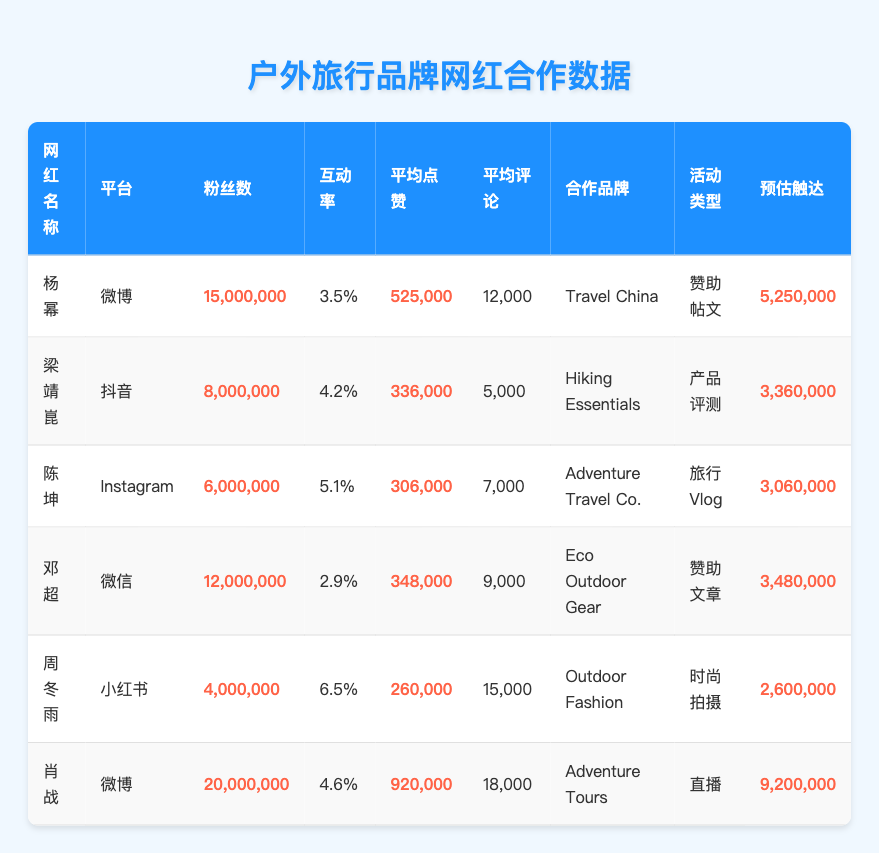What is the engagement rate of Yang Mi? To find the engagement rate for Yang Mi, look at the row corresponding to her name and find the engagement rate value, which is 3.5%.
Answer: 3.5% How many average likes does Xiao Zhan receive? Refer to the row for Xiao Zhan and locate the average likes column; he has an average of 920,000 likes.
Answer: 920,000 Which influencer has the highest number of followers? Check each row's follower count; Xiao Zhan has the highest with 20,000,000 followers.
Answer: 20,000,000 What is the estimated reach of Zhou Dongyu's collaboration? Look at the row for Zhou Dongyu and find the estimated reach value listed as 2,600,000.
Answer: 2,600,000 Which platform does Liang Jingkun use? Identify the row for Liang Jingkun and check the platform column, which shows Douyin.
Answer: Douyin What is the difference in average likes between Chen Kun and Deng Chao? Find the average likes for Chen Kun (306,000) and Deng Chao (348,000). Then calculate the difference: 348,000 - 306,000 = 42,000.
Answer: 42,000 Which influencer has the highest engagement rate? Review the engagement rates of all influencers; Zhou Dongyu has the highest engagement rate of 6.5%.
Answer: 6.5% What is the combined estimated reach of all influencers in the table? Sum the estimated reach of each influencer: 5,250,000 + 3,360,000 + 3,060,000 + 3,480,000 + 2,600,000 + 9,200,000 = 26,950,000.
Answer: 26,950,000 Does Chen Kun have more followers than Deng Chao? Compare the followers of Chen Kun (6,000,000) and Deng Chao (12,000,000); Chen Kun has fewer followers than Deng Chao.
Answer: No Which influencer collaborates with Adventure Travel Co.? Look for the brand Adventure Travel Co. in the collaboration brand column; it corresponds to Chen Kun.
Answer: Chen Kun What is the average engagement rate among all influencers listed? Calculate using the engagement rates: (3.5% + 4.2% + 5.1% + 2.9% + 6.5% + 4.6%) / 6 = 4.33%.
Answer: 4.33% 